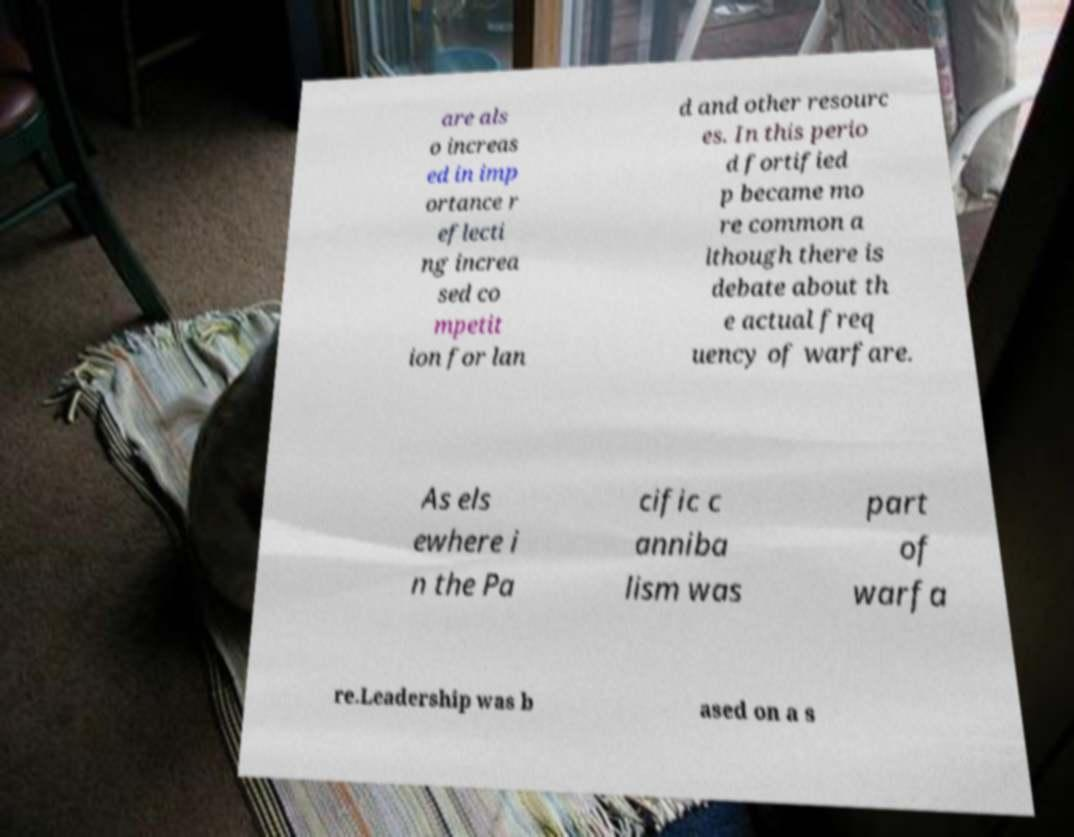Can you read and provide the text displayed in the image?This photo seems to have some interesting text. Can you extract and type it out for me? are als o increas ed in imp ortance r eflecti ng increa sed co mpetit ion for lan d and other resourc es. In this perio d fortified p became mo re common a lthough there is debate about th e actual freq uency of warfare. As els ewhere i n the Pa cific c anniba lism was part of warfa re.Leadership was b ased on a s 